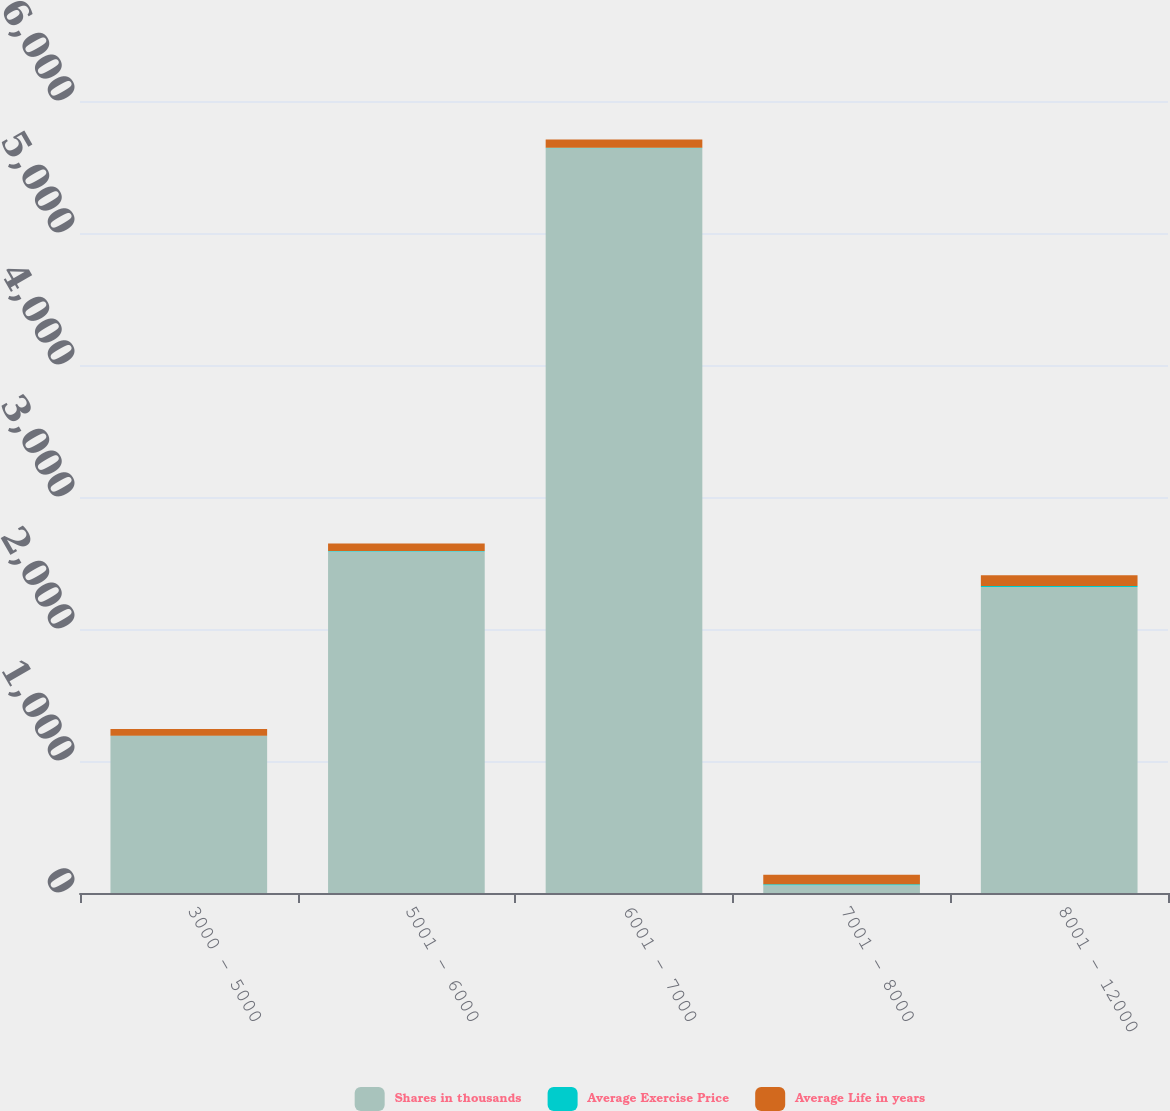<chart> <loc_0><loc_0><loc_500><loc_500><stacked_bar_chart><ecel><fcel>3000 - 5000<fcel>5001 - 6000<fcel>6001 - 7000<fcel>7001 - 8000<fcel>8001 - 12000<nl><fcel>Shares in thousands<fcel>1190<fcel>2587<fcel>5642<fcel>59.07<fcel>2318<nl><fcel>Average Exercise Price<fcel>1.86<fcel>3.21<fcel>4.76<fcel>7.75<fcel>8.28<nl><fcel>Average Life in years<fcel>49.95<fcel>56.97<fcel>61.17<fcel>71.22<fcel>81.11<nl></chart> 